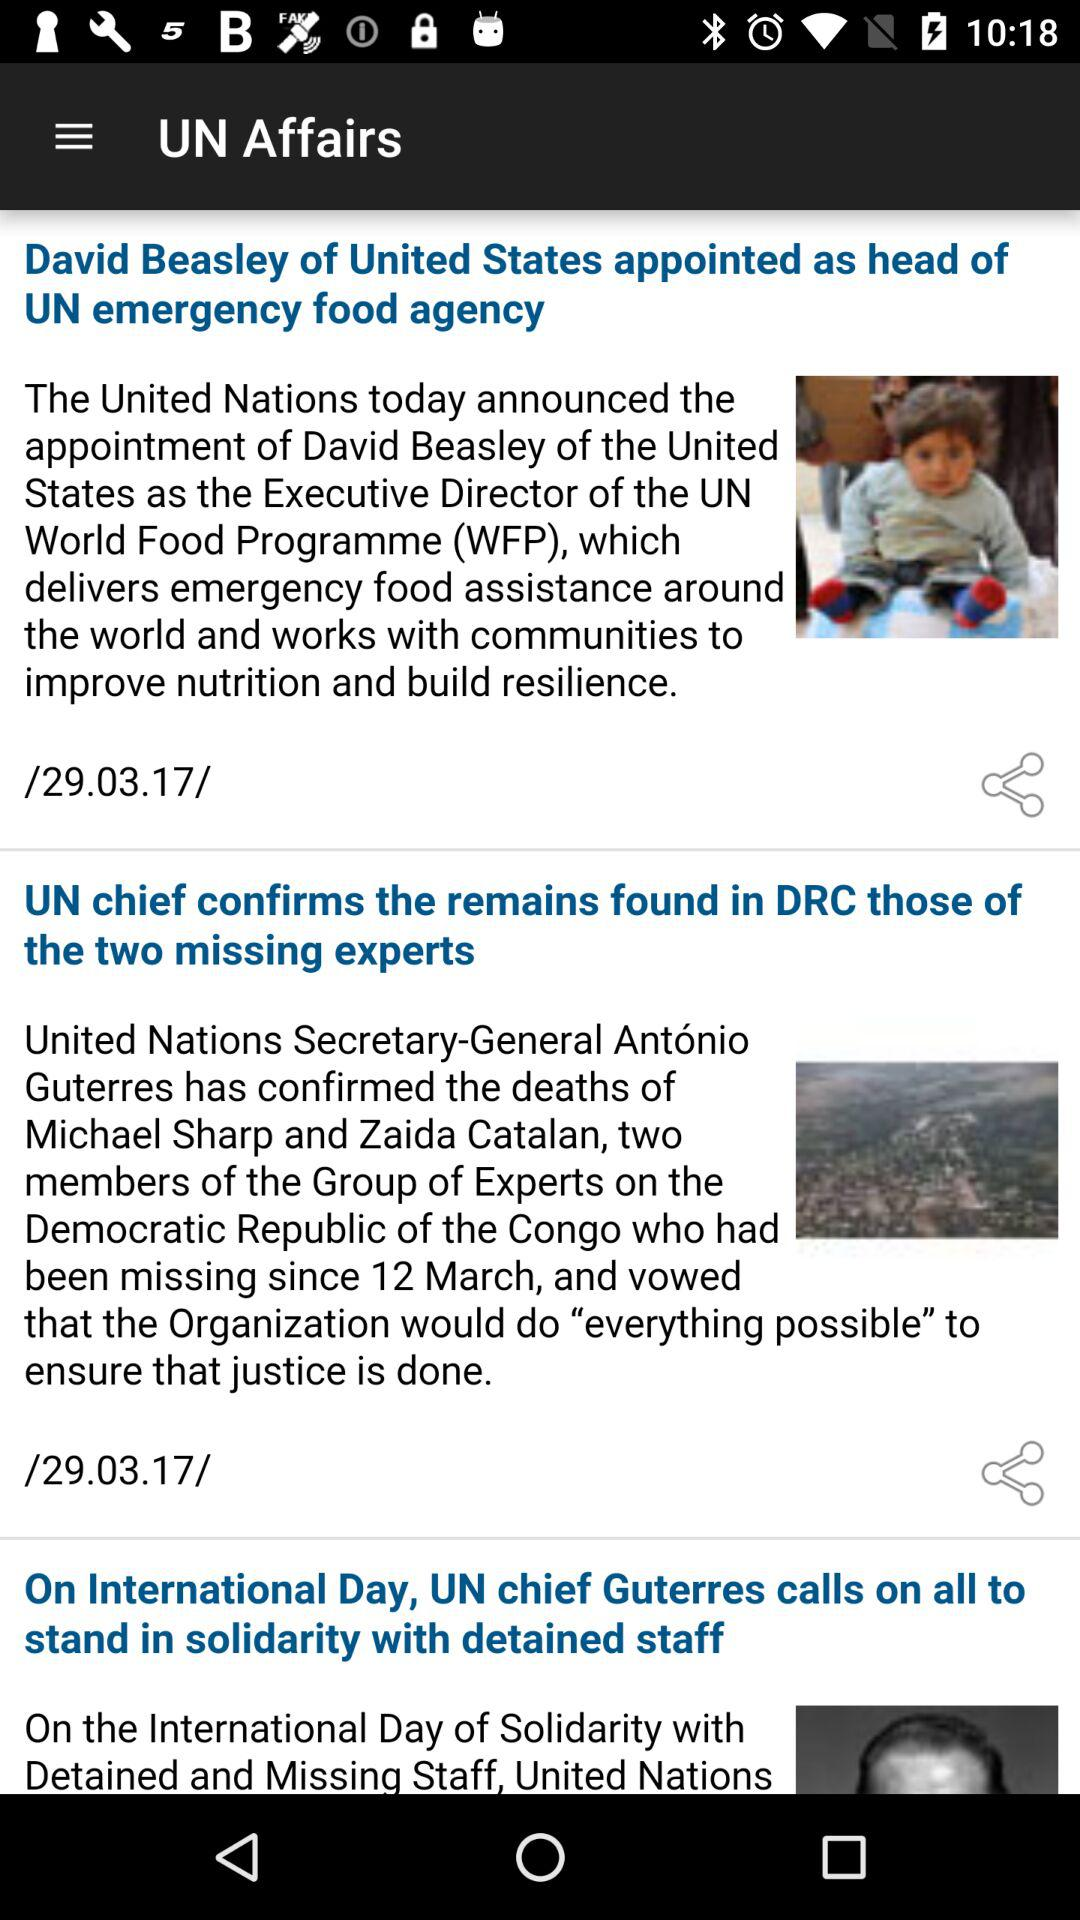On what date the news "David Beasley of United States appointed as head of UN emergency food agency" is updated? The date is 29.03.17. 